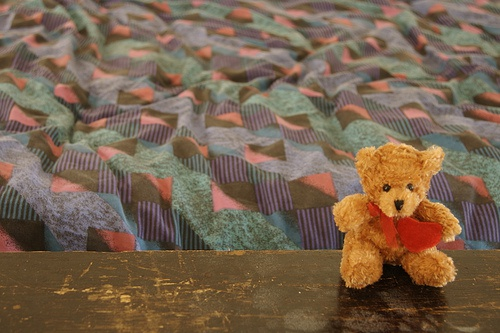Describe the objects in this image and their specific colors. I can see bed in maroon and gray tones and teddy bear in maroon, red, orange, and brown tones in this image. 